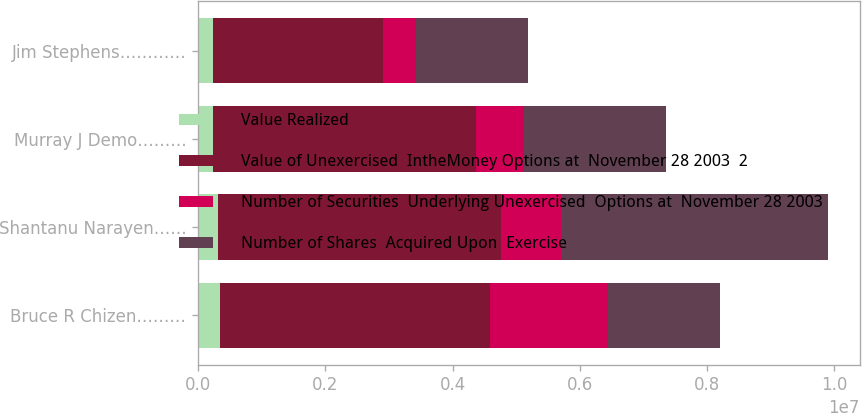<chart> <loc_0><loc_0><loc_500><loc_500><stacked_bar_chart><ecel><fcel>Bruce R Chizen………<fcel>Shantanu Narayen……<fcel>Murray J Demo………<fcel>Jim Stephens…………<nl><fcel>Value Realized<fcel>350000<fcel>310150<fcel>243325<fcel>241666<nl><fcel>Value of Unexercised  IntheMoney Options at  November 28 2003  2<fcel>4.246e+06<fcel>4.44344e+06<fcel>4.12479e+06<fcel>2.67224e+06<nl><fcel>Number of Securities  Underlying Unexercised  Options at  November 28 2003<fcel>1.85324e+06<fcel>947589<fcel>758706<fcel>508958<nl><fcel>Number of Shares  Acquired Upon  Exercise<fcel>1.7549e+06<fcel>4.20038e+06<fcel>2.22607e+06<fcel>1.7549e+06<nl></chart> 